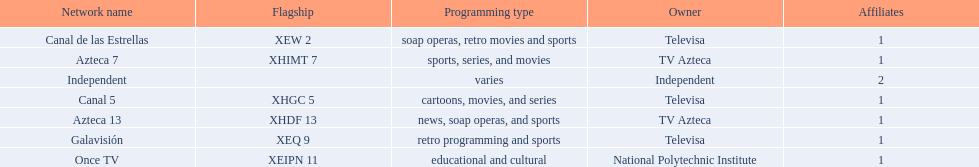How many affiliates does galavision have? 1. 